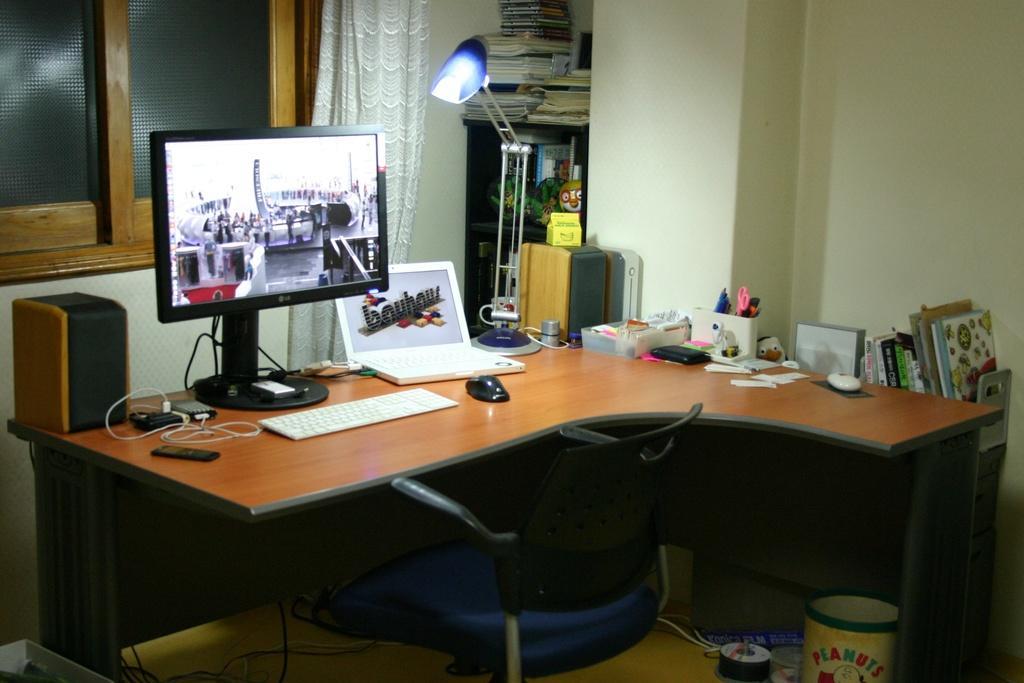How would you summarize this image in a sentence or two? In this picture we can see a chair and a table, there is a keyboard, a mouse, a laptop, wires, a speaker, a lamp, papers, pen stand and other things present on the table, on the right side there are some books, on the left side we can see a window, there are some books and a curtain in the middle, in the background there is a wall. 